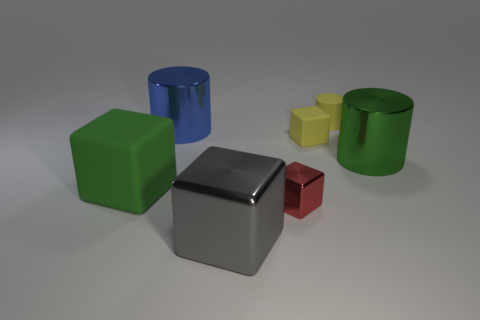How many rubber things are either big red objects or blue cylinders?
Your answer should be very brief. 0. What is the size of the green object behind the green thing left of the tiny shiny cube?
Your answer should be very brief. Large. What material is the large thing that is the same color as the large matte block?
Keep it short and to the point. Metal. Is there a tiny yellow rubber object in front of the green thing to the right of the big metal thing behind the small matte cube?
Offer a terse response. No. Does the yellow cylinder that is behind the big gray object have the same material as the yellow block on the left side of the green metallic thing?
Keep it short and to the point. Yes. What number of things are brown rubber cylinders or big cubes that are right of the green rubber cube?
Offer a very short reply. 1. What number of matte things are the same shape as the large green shiny thing?
Provide a succinct answer. 1. What material is the other block that is the same size as the gray metallic block?
Make the answer very short. Rubber. There is a green object left of the red metal block to the right of the green object on the left side of the large blue cylinder; what size is it?
Your answer should be compact. Large. There is a metallic block that is on the left side of the small red shiny cube; is it the same color as the small block that is behind the big green rubber object?
Your answer should be compact. No. 